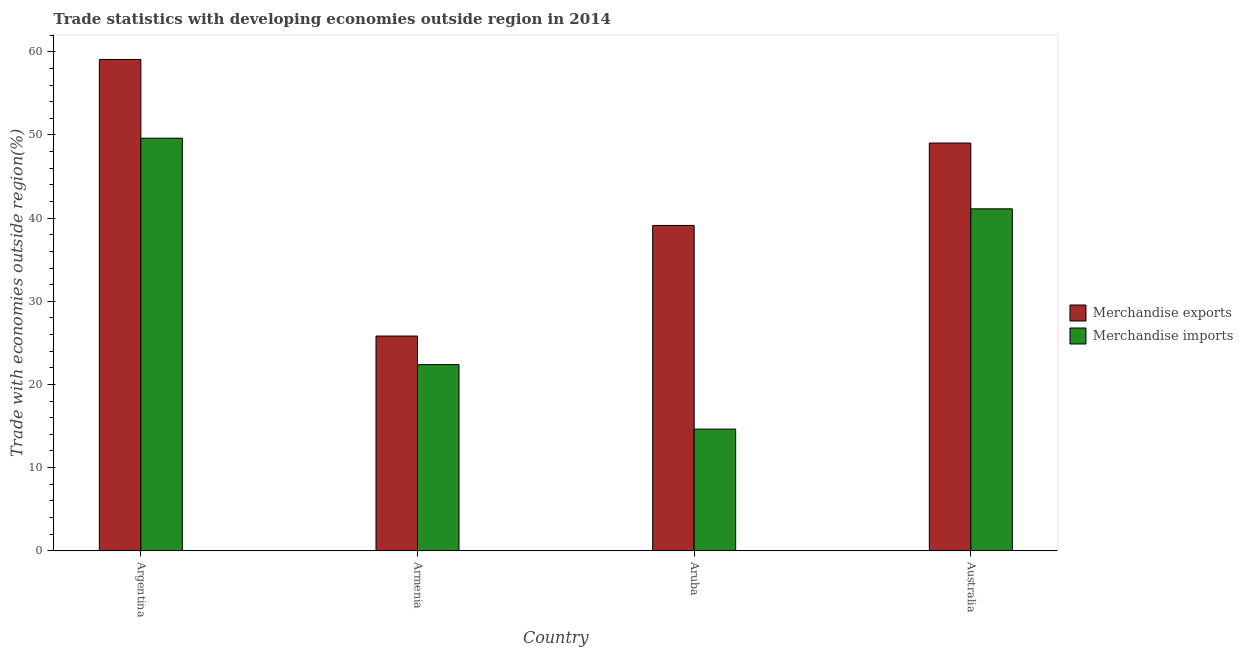How many different coloured bars are there?
Offer a very short reply. 2. How many bars are there on the 4th tick from the left?
Offer a terse response. 2. What is the label of the 3rd group of bars from the left?
Give a very brief answer. Aruba. In how many cases, is the number of bars for a given country not equal to the number of legend labels?
Make the answer very short. 0. What is the merchandise exports in Armenia?
Your response must be concise. 25.82. Across all countries, what is the maximum merchandise exports?
Keep it short and to the point. 59.08. Across all countries, what is the minimum merchandise exports?
Give a very brief answer. 25.82. In which country was the merchandise imports maximum?
Provide a succinct answer. Argentina. In which country was the merchandise exports minimum?
Ensure brevity in your answer.  Armenia. What is the total merchandise exports in the graph?
Offer a terse response. 173.06. What is the difference between the merchandise exports in Argentina and that in Australia?
Keep it short and to the point. 10.05. What is the difference between the merchandise imports in Argentina and the merchandise exports in Armenia?
Your answer should be compact. 23.79. What is the average merchandise imports per country?
Ensure brevity in your answer.  31.94. What is the difference between the merchandise exports and merchandise imports in Armenia?
Offer a terse response. 3.44. In how many countries, is the merchandise exports greater than 26 %?
Your response must be concise. 3. What is the ratio of the merchandise imports in Armenia to that in Aruba?
Your answer should be very brief. 1.53. Is the merchandise exports in Argentina less than that in Australia?
Provide a short and direct response. No. Is the difference between the merchandise imports in Armenia and Australia greater than the difference between the merchandise exports in Armenia and Australia?
Provide a succinct answer. Yes. What is the difference between the highest and the second highest merchandise exports?
Provide a short and direct response. 10.05. What is the difference between the highest and the lowest merchandise imports?
Your answer should be compact. 34.98. In how many countries, is the merchandise exports greater than the average merchandise exports taken over all countries?
Give a very brief answer. 2. Is the sum of the merchandise exports in Argentina and Aruba greater than the maximum merchandise imports across all countries?
Your answer should be very brief. Yes. What does the 1st bar from the right in Aruba represents?
Provide a succinct answer. Merchandise imports. How many bars are there?
Ensure brevity in your answer.  8. Are all the bars in the graph horizontal?
Provide a succinct answer. No. How many countries are there in the graph?
Make the answer very short. 4. Are the values on the major ticks of Y-axis written in scientific E-notation?
Make the answer very short. No. Does the graph contain any zero values?
Make the answer very short. No. Where does the legend appear in the graph?
Your answer should be very brief. Center right. How many legend labels are there?
Keep it short and to the point. 2. What is the title of the graph?
Give a very brief answer. Trade statistics with developing economies outside region in 2014. Does "Automatic Teller Machines" appear as one of the legend labels in the graph?
Your answer should be very brief. No. What is the label or title of the Y-axis?
Your answer should be compact. Trade with economies outside region(%). What is the Trade with economies outside region(%) of Merchandise exports in Argentina?
Your answer should be compact. 59.08. What is the Trade with economies outside region(%) of Merchandise imports in Argentina?
Provide a short and direct response. 49.61. What is the Trade with economies outside region(%) of Merchandise exports in Armenia?
Offer a terse response. 25.82. What is the Trade with economies outside region(%) of Merchandise imports in Armenia?
Make the answer very short. 22.38. What is the Trade with economies outside region(%) in Merchandise exports in Aruba?
Your answer should be compact. 39.12. What is the Trade with economies outside region(%) in Merchandise imports in Aruba?
Make the answer very short. 14.63. What is the Trade with economies outside region(%) in Merchandise exports in Australia?
Give a very brief answer. 49.03. What is the Trade with economies outside region(%) in Merchandise imports in Australia?
Ensure brevity in your answer.  41.12. Across all countries, what is the maximum Trade with economies outside region(%) in Merchandise exports?
Provide a short and direct response. 59.08. Across all countries, what is the maximum Trade with economies outside region(%) in Merchandise imports?
Offer a very short reply. 49.61. Across all countries, what is the minimum Trade with economies outside region(%) of Merchandise exports?
Your answer should be compact. 25.82. Across all countries, what is the minimum Trade with economies outside region(%) in Merchandise imports?
Your answer should be compact. 14.63. What is the total Trade with economies outside region(%) of Merchandise exports in the graph?
Provide a succinct answer. 173.06. What is the total Trade with economies outside region(%) in Merchandise imports in the graph?
Keep it short and to the point. 127.75. What is the difference between the Trade with economies outside region(%) in Merchandise exports in Argentina and that in Armenia?
Keep it short and to the point. 33.26. What is the difference between the Trade with economies outside region(%) of Merchandise imports in Argentina and that in Armenia?
Provide a succinct answer. 27.23. What is the difference between the Trade with economies outside region(%) in Merchandise exports in Argentina and that in Aruba?
Ensure brevity in your answer.  19.96. What is the difference between the Trade with economies outside region(%) in Merchandise imports in Argentina and that in Aruba?
Ensure brevity in your answer.  34.98. What is the difference between the Trade with economies outside region(%) of Merchandise exports in Argentina and that in Australia?
Your response must be concise. 10.05. What is the difference between the Trade with economies outside region(%) in Merchandise imports in Argentina and that in Australia?
Offer a very short reply. 8.49. What is the difference between the Trade with economies outside region(%) of Merchandise exports in Armenia and that in Aruba?
Give a very brief answer. -13.3. What is the difference between the Trade with economies outside region(%) of Merchandise imports in Armenia and that in Aruba?
Keep it short and to the point. 7.75. What is the difference between the Trade with economies outside region(%) of Merchandise exports in Armenia and that in Australia?
Provide a short and direct response. -23.21. What is the difference between the Trade with economies outside region(%) of Merchandise imports in Armenia and that in Australia?
Ensure brevity in your answer.  -18.73. What is the difference between the Trade with economies outside region(%) in Merchandise exports in Aruba and that in Australia?
Give a very brief answer. -9.91. What is the difference between the Trade with economies outside region(%) of Merchandise imports in Aruba and that in Australia?
Offer a very short reply. -26.49. What is the difference between the Trade with economies outside region(%) in Merchandise exports in Argentina and the Trade with economies outside region(%) in Merchandise imports in Armenia?
Provide a succinct answer. 36.7. What is the difference between the Trade with economies outside region(%) of Merchandise exports in Argentina and the Trade with economies outside region(%) of Merchandise imports in Aruba?
Your answer should be very brief. 44.45. What is the difference between the Trade with economies outside region(%) of Merchandise exports in Argentina and the Trade with economies outside region(%) of Merchandise imports in Australia?
Your response must be concise. 17.96. What is the difference between the Trade with economies outside region(%) in Merchandise exports in Armenia and the Trade with economies outside region(%) in Merchandise imports in Aruba?
Your response must be concise. 11.19. What is the difference between the Trade with economies outside region(%) in Merchandise exports in Armenia and the Trade with economies outside region(%) in Merchandise imports in Australia?
Provide a succinct answer. -15.3. What is the difference between the Trade with economies outside region(%) in Merchandise exports in Aruba and the Trade with economies outside region(%) in Merchandise imports in Australia?
Keep it short and to the point. -2. What is the average Trade with economies outside region(%) of Merchandise exports per country?
Offer a terse response. 43.26. What is the average Trade with economies outside region(%) of Merchandise imports per country?
Your response must be concise. 31.94. What is the difference between the Trade with economies outside region(%) in Merchandise exports and Trade with economies outside region(%) in Merchandise imports in Argentina?
Your answer should be very brief. 9.47. What is the difference between the Trade with economies outside region(%) in Merchandise exports and Trade with economies outside region(%) in Merchandise imports in Armenia?
Your response must be concise. 3.44. What is the difference between the Trade with economies outside region(%) in Merchandise exports and Trade with economies outside region(%) in Merchandise imports in Aruba?
Your response must be concise. 24.49. What is the difference between the Trade with economies outside region(%) in Merchandise exports and Trade with economies outside region(%) in Merchandise imports in Australia?
Offer a terse response. 7.91. What is the ratio of the Trade with economies outside region(%) in Merchandise exports in Argentina to that in Armenia?
Provide a succinct answer. 2.29. What is the ratio of the Trade with economies outside region(%) of Merchandise imports in Argentina to that in Armenia?
Offer a very short reply. 2.22. What is the ratio of the Trade with economies outside region(%) of Merchandise exports in Argentina to that in Aruba?
Give a very brief answer. 1.51. What is the ratio of the Trade with economies outside region(%) of Merchandise imports in Argentina to that in Aruba?
Give a very brief answer. 3.39. What is the ratio of the Trade with economies outside region(%) of Merchandise exports in Argentina to that in Australia?
Keep it short and to the point. 1.21. What is the ratio of the Trade with economies outside region(%) of Merchandise imports in Argentina to that in Australia?
Your response must be concise. 1.21. What is the ratio of the Trade with economies outside region(%) in Merchandise exports in Armenia to that in Aruba?
Your answer should be compact. 0.66. What is the ratio of the Trade with economies outside region(%) in Merchandise imports in Armenia to that in Aruba?
Your response must be concise. 1.53. What is the ratio of the Trade with economies outside region(%) in Merchandise exports in Armenia to that in Australia?
Ensure brevity in your answer.  0.53. What is the ratio of the Trade with economies outside region(%) of Merchandise imports in Armenia to that in Australia?
Offer a terse response. 0.54. What is the ratio of the Trade with economies outside region(%) in Merchandise exports in Aruba to that in Australia?
Make the answer very short. 0.8. What is the ratio of the Trade with economies outside region(%) of Merchandise imports in Aruba to that in Australia?
Ensure brevity in your answer.  0.36. What is the difference between the highest and the second highest Trade with economies outside region(%) of Merchandise exports?
Make the answer very short. 10.05. What is the difference between the highest and the second highest Trade with economies outside region(%) of Merchandise imports?
Your response must be concise. 8.49. What is the difference between the highest and the lowest Trade with economies outside region(%) of Merchandise exports?
Provide a succinct answer. 33.26. What is the difference between the highest and the lowest Trade with economies outside region(%) of Merchandise imports?
Provide a short and direct response. 34.98. 